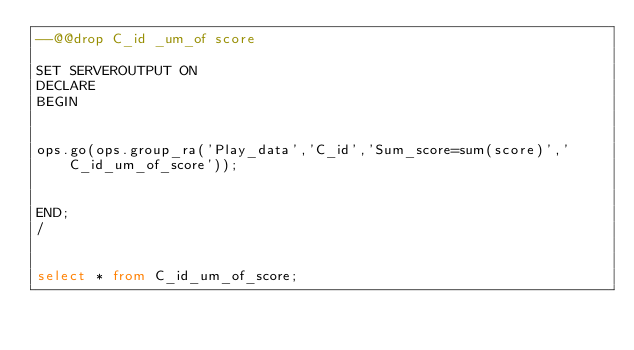<code> <loc_0><loc_0><loc_500><loc_500><_SQL_>--@@drop C_id _um_of score

SET SERVEROUTPUT ON
DECLARE
BEGIN


ops.go(ops.group_ra('Play_data','C_id','Sum_score=sum(score)','C_id_um_of_score'));


END;
/


select * from C_id_um_of_score;</code> 